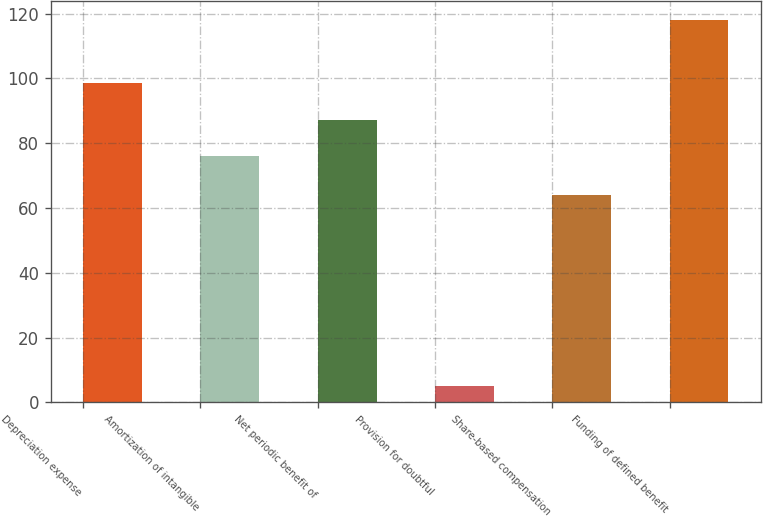<chart> <loc_0><loc_0><loc_500><loc_500><bar_chart><fcel>Depreciation expense<fcel>Amortization of intangible<fcel>Net periodic benefit of<fcel>Provision for doubtful<fcel>Share-based compensation<fcel>Funding of defined benefit<nl><fcel>98.6<fcel>76<fcel>87.3<fcel>5<fcel>64<fcel>118<nl></chart> 